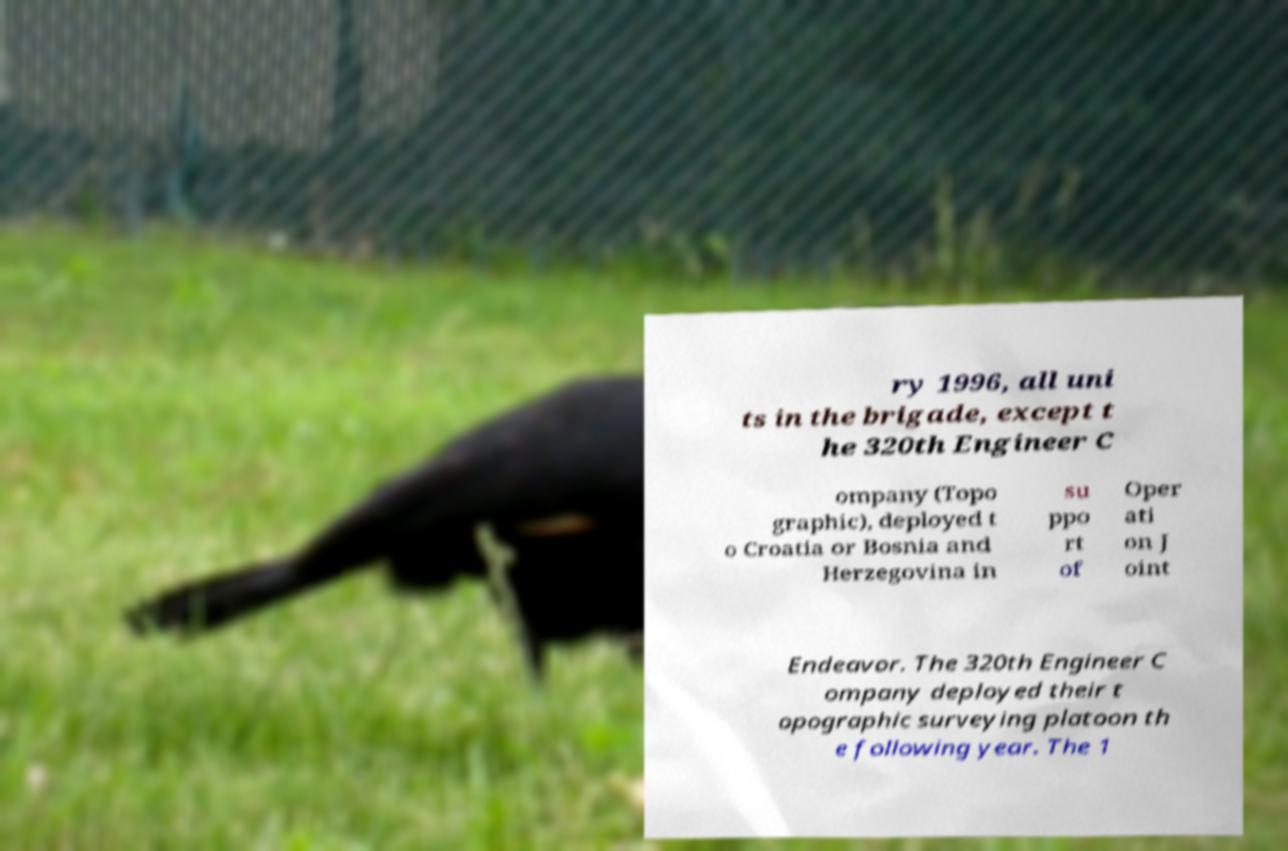There's text embedded in this image that I need extracted. Can you transcribe it verbatim? ry 1996, all uni ts in the brigade, except t he 320th Engineer C ompany (Topo graphic), deployed t o Croatia or Bosnia and Herzegovina in su ppo rt of Oper ati on J oint Endeavor. The 320th Engineer C ompany deployed their t opographic surveying platoon th e following year. The 1 